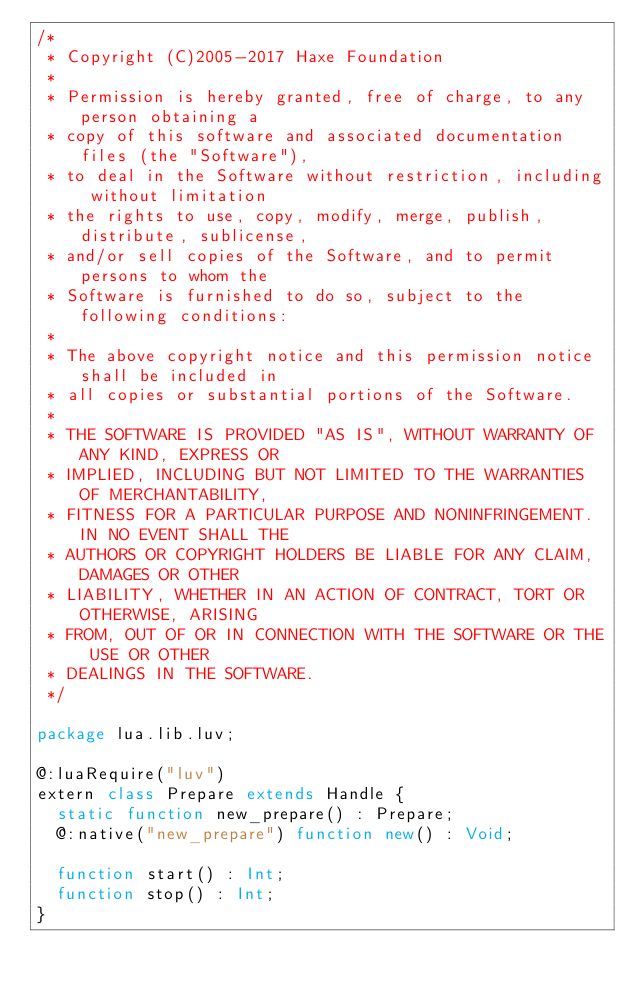<code> <loc_0><loc_0><loc_500><loc_500><_Haxe_>/*
 * Copyright (C)2005-2017 Haxe Foundation
 *
 * Permission is hereby granted, free of charge, to any person obtaining a
 * copy of this software and associated documentation files (the "Software"),
 * to deal in the Software without restriction, including without limitation
 * the rights to use, copy, modify, merge, publish, distribute, sublicense,
 * and/or sell copies of the Software, and to permit persons to whom the
 * Software is furnished to do so, subject to the following conditions:
 *
 * The above copyright notice and this permission notice shall be included in
 * all copies or substantial portions of the Software.
 *
 * THE SOFTWARE IS PROVIDED "AS IS", WITHOUT WARRANTY OF ANY KIND, EXPRESS OR
 * IMPLIED, INCLUDING BUT NOT LIMITED TO THE WARRANTIES OF MERCHANTABILITY,
 * FITNESS FOR A PARTICULAR PURPOSE AND NONINFRINGEMENT. IN NO EVENT SHALL THE
 * AUTHORS OR COPYRIGHT HOLDERS BE LIABLE FOR ANY CLAIM, DAMAGES OR OTHER
 * LIABILITY, WHETHER IN AN ACTION OF CONTRACT, TORT OR OTHERWISE, ARISING
 * FROM, OUT OF OR IN CONNECTION WITH THE SOFTWARE OR THE USE OR OTHER
 * DEALINGS IN THE SOFTWARE.
 */

package lua.lib.luv;

@:luaRequire("luv")
extern class Prepare extends Handle {
  static function new_prepare() : Prepare;
  @:native("new_prepare") function new() : Void;

  function start() : Int;
  function stop() : Int;
}
</code> 